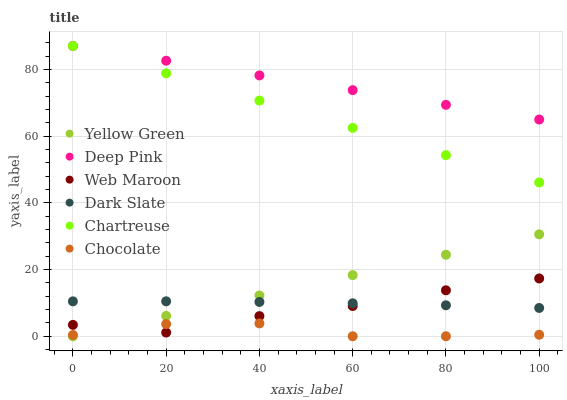Does Chocolate have the minimum area under the curve?
Answer yes or no. Yes. Does Deep Pink have the maximum area under the curve?
Answer yes or no. Yes. Does Yellow Green have the minimum area under the curve?
Answer yes or no. No. Does Yellow Green have the maximum area under the curve?
Answer yes or no. No. Is Yellow Green the smoothest?
Answer yes or no. Yes. Is Web Maroon the roughest?
Answer yes or no. Yes. Is Web Maroon the smoothest?
Answer yes or no. No. Is Yellow Green the roughest?
Answer yes or no. No. Does Yellow Green have the lowest value?
Answer yes or no. Yes. Does Web Maroon have the lowest value?
Answer yes or no. No. Does Chartreuse have the highest value?
Answer yes or no. Yes. Does Yellow Green have the highest value?
Answer yes or no. No. Is Dark Slate less than Chartreuse?
Answer yes or no. Yes. Is Deep Pink greater than Yellow Green?
Answer yes or no. Yes. Does Web Maroon intersect Dark Slate?
Answer yes or no. Yes. Is Web Maroon less than Dark Slate?
Answer yes or no. No. Is Web Maroon greater than Dark Slate?
Answer yes or no. No. Does Dark Slate intersect Chartreuse?
Answer yes or no. No. 